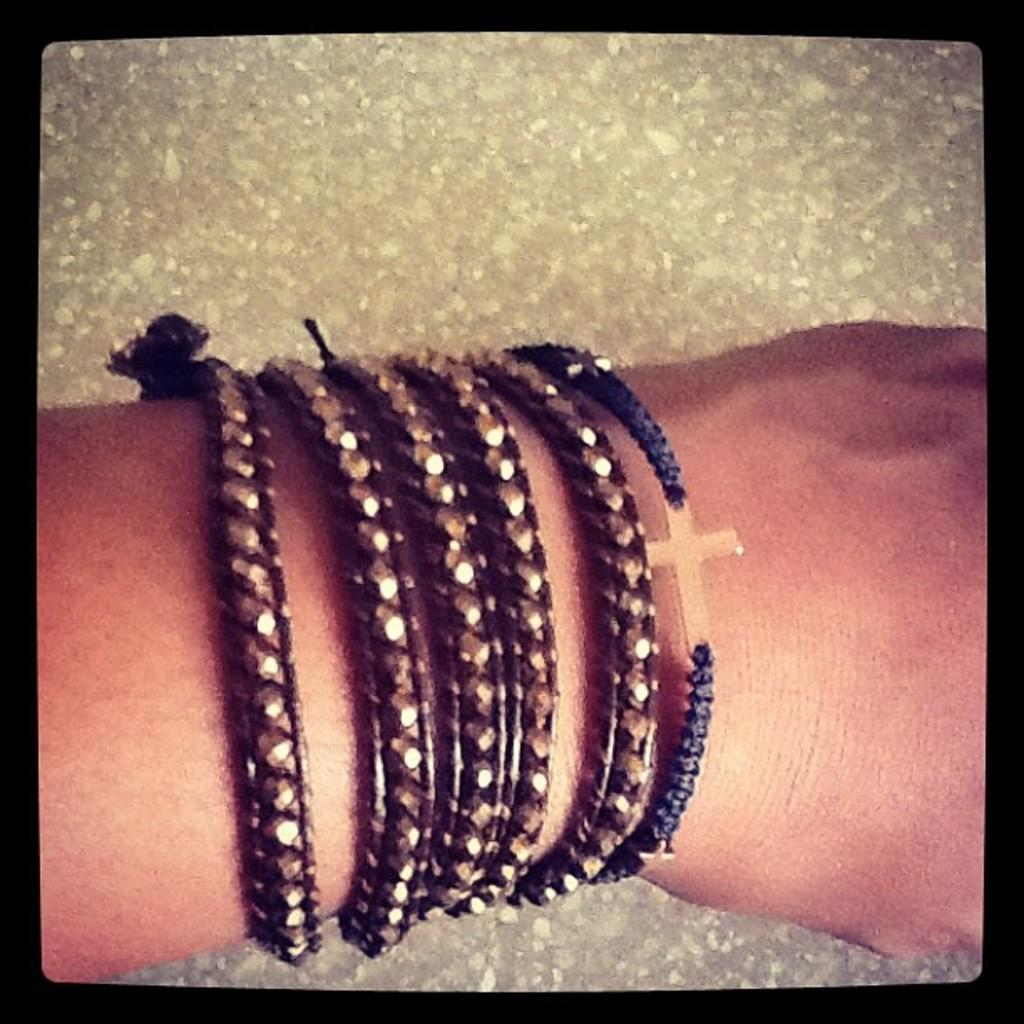What part of a person is visible in the image? There is a hand of a person in the image. What is on the hand? There are bands on the hand. Where is the mom sitting with her bun in the image? There is no mom or bun present in the image; only a hand with bands is visible. 